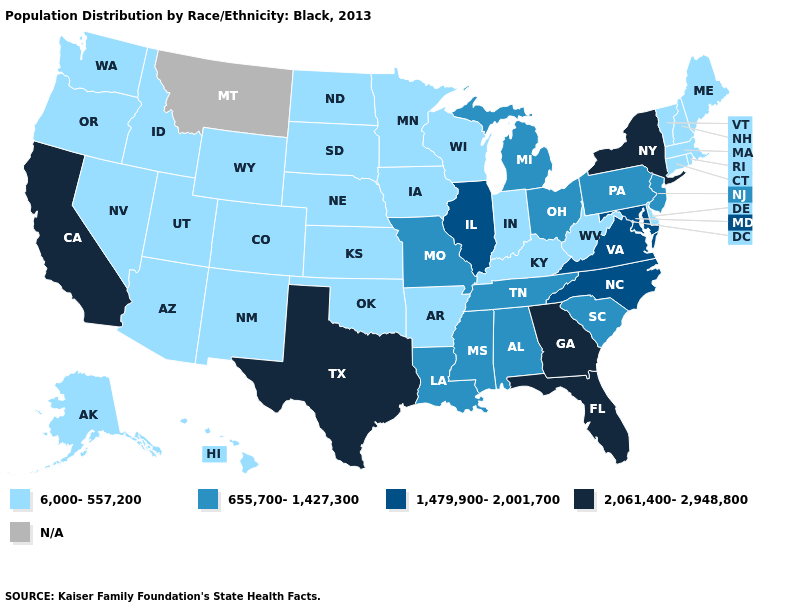What is the value of Alabama?
Give a very brief answer. 655,700-1,427,300. Name the states that have a value in the range 2,061,400-2,948,800?
Give a very brief answer. California, Florida, Georgia, New York, Texas. Name the states that have a value in the range 2,061,400-2,948,800?
Write a very short answer. California, Florida, Georgia, New York, Texas. How many symbols are there in the legend?
Give a very brief answer. 5. What is the lowest value in the South?
Keep it brief. 6,000-557,200. Does Vermont have the lowest value in the Northeast?
Quick response, please. Yes. Among the states that border Oklahoma , which have the lowest value?
Concise answer only. Arkansas, Colorado, Kansas, New Mexico. Which states hav the highest value in the Northeast?
Answer briefly. New York. Name the states that have a value in the range 1,479,900-2,001,700?
Give a very brief answer. Illinois, Maryland, North Carolina, Virginia. Name the states that have a value in the range 1,479,900-2,001,700?
Be succinct. Illinois, Maryland, North Carolina, Virginia. What is the value of Michigan?
Be succinct. 655,700-1,427,300. Name the states that have a value in the range 6,000-557,200?
Answer briefly. Alaska, Arizona, Arkansas, Colorado, Connecticut, Delaware, Hawaii, Idaho, Indiana, Iowa, Kansas, Kentucky, Maine, Massachusetts, Minnesota, Nebraska, Nevada, New Hampshire, New Mexico, North Dakota, Oklahoma, Oregon, Rhode Island, South Dakota, Utah, Vermont, Washington, West Virginia, Wisconsin, Wyoming. What is the value of New York?
Be succinct. 2,061,400-2,948,800. Which states have the highest value in the USA?
Quick response, please. California, Florida, Georgia, New York, Texas. 